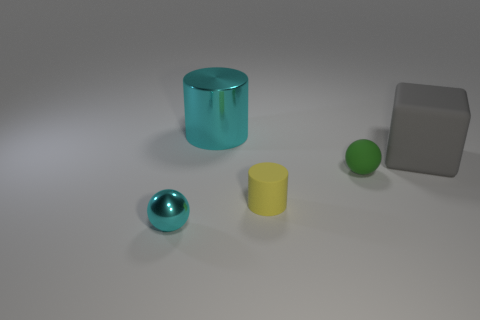Add 4 small brown rubber balls. How many objects exist? 9 Subtract all cylinders. How many objects are left? 3 Add 2 big gray objects. How many big gray objects are left? 3 Add 2 tiny green objects. How many tiny green objects exist? 3 Subtract 0 red cubes. How many objects are left? 5 Subtract all small yellow things. Subtract all large gray rubber balls. How many objects are left? 4 